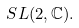<formula> <loc_0><loc_0><loc_500><loc_500>S L ( 2 , \mathbb { C } ) .</formula> 